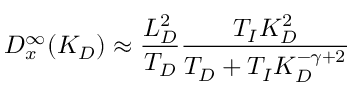<formula> <loc_0><loc_0><loc_500><loc_500>D _ { x } ^ { \infty } ( K _ { D } ) \approx \frac { L _ { D } ^ { 2 } } { T _ { D } } \frac { T _ { I } K _ { D } ^ { 2 } } { T _ { D } + T _ { I } K _ { D } ^ { - \gamma + 2 } }</formula> 